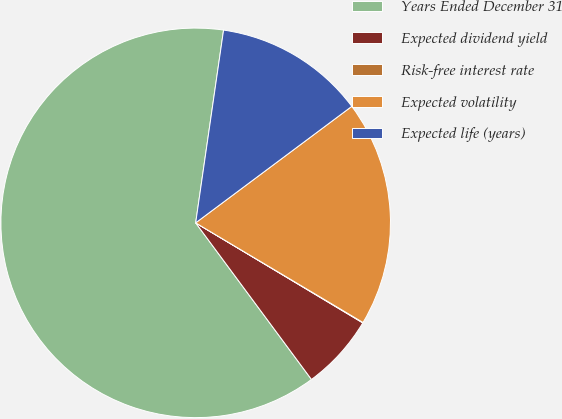Convert chart to OTSL. <chart><loc_0><loc_0><loc_500><loc_500><pie_chart><fcel>Years Ended December 31<fcel>Expected dividend yield<fcel>Risk-free interest rate<fcel>Expected volatility<fcel>Expected life (years)<nl><fcel>62.42%<fcel>6.28%<fcel>0.04%<fcel>18.75%<fcel>12.51%<nl></chart> 